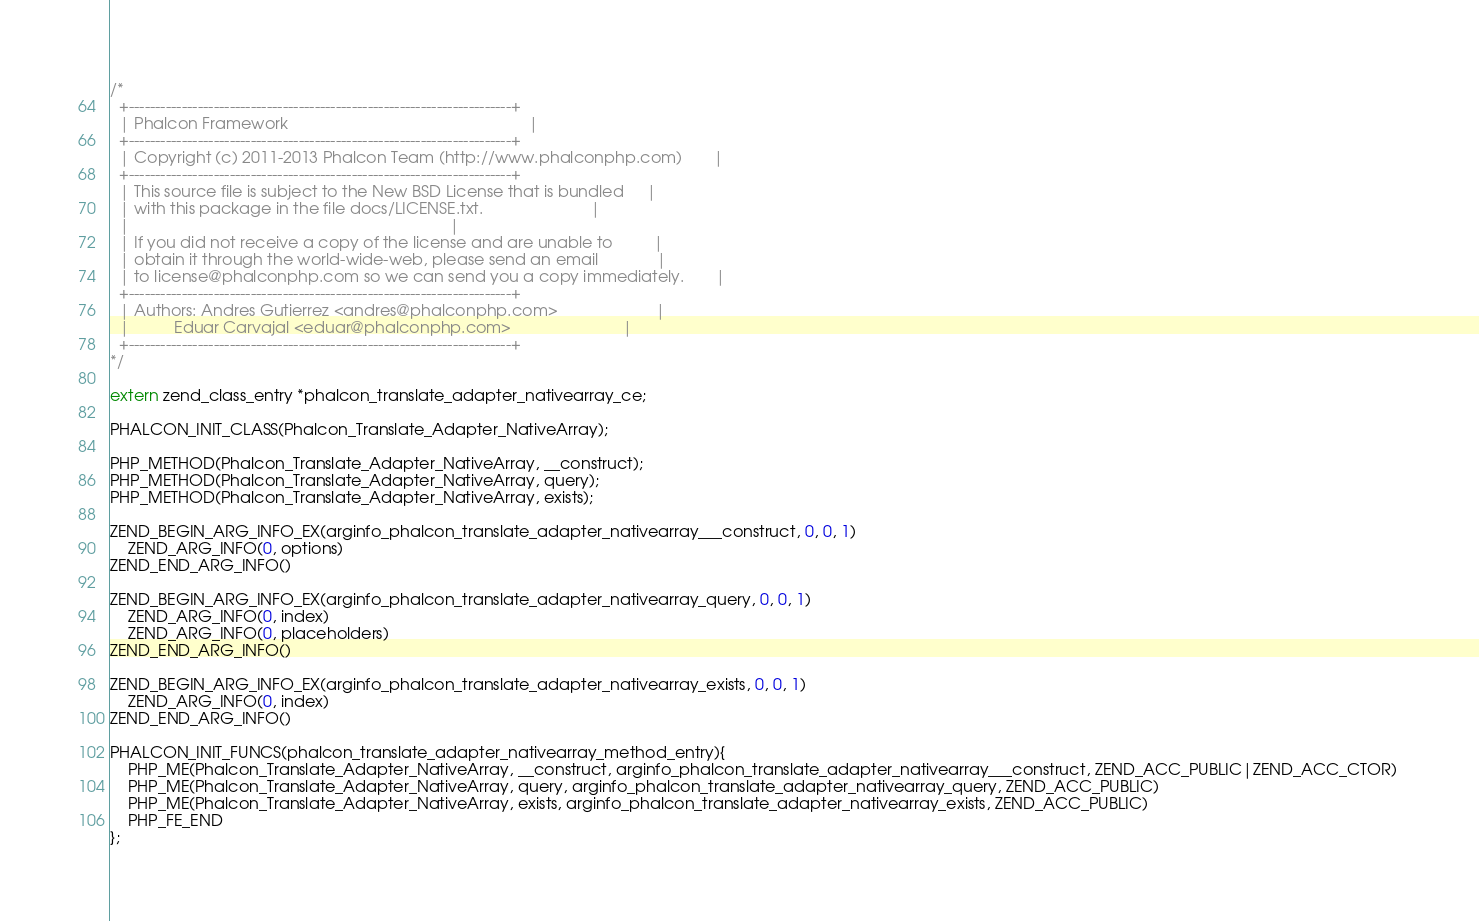<code> <loc_0><loc_0><loc_500><loc_500><_C_>
/*
  +------------------------------------------------------------------------+
  | Phalcon Framework                                                      |
  +------------------------------------------------------------------------+
  | Copyright (c) 2011-2013 Phalcon Team (http://www.phalconphp.com)       |
  +------------------------------------------------------------------------+
  | This source file is subject to the New BSD License that is bundled     |
  | with this package in the file docs/LICENSE.txt.                        |
  |                                                                        |
  | If you did not receive a copy of the license and are unable to         |
  | obtain it through the world-wide-web, please send an email             |
  | to license@phalconphp.com so we can send you a copy immediately.       |
  +------------------------------------------------------------------------+
  | Authors: Andres Gutierrez <andres@phalconphp.com>                      |
  |          Eduar Carvajal <eduar@phalconphp.com>                         |
  +------------------------------------------------------------------------+
*/

extern zend_class_entry *phalcon_translate_adapter_nativearray_ce;

PHALCON_INIT_CLASS(Phalcon_Translate_Adapter_NativeArray);

PHP_METHOD(Phalcon_Translate_Adapter_NativeArray, __construct);
PHP_METHOD(Phalcon_Translate_Adapter_NativeArray, query);
PHP_METHOD(Phalcon_Translate_Adapter_NativeArray, exists);

ZEND_BEGIN_ARG_INFO_EX(arginfo_phalcon_translate_adapter_nativearray___construct, 0, 0, 1)
	ZEND_ARG_INFO(0, options)
ZEND_END_ARG_INFO()

ZEND_BEGIN_ARG_INFO_EX(arginfo_phalcon_translate_adapter_nativearray_query, 0, 0, 1)
	ZEND_ARG_INFO(0, index)
	ZEND_ARG_INFO(0, placeholders)
ZEND_END_ARG_INFO()

ZEND_BEGIN_ARG_INFO_EX(arginfo_phalcon_translate_adapter_nativearray_exists, 0, 0, 1)
	ZEND_ARG_INFO(0, index)
ZEND_END_ARG_INFO()

PHALCON_INIT_FUNCS(phalcon_translate_adapter_nativearray_method_entry){
	PHP_ME(Phalcon_Translate_Adapter_NativeArray, __construct, arginfo_phalcon_translate_adapter_nativearray___construct, ZEND_ACC_PUBLIC|ZEND_ACC_CTOR) 
	PHP_ME(Phalcon_Translate_Adapter_NativeArray, query, arginfo_phalcon_translate_adapter_nativearray_query, ZEND_ACC_PUBLIC) 
	PHP_ME(Phalcon_Translate_Adapter_NativeArray, exists, arginfo_phalcon_translate_adapter_nativearray_exists, ZEND_ACC_PUBLIC) 
	PHP_FE_END
};

</code> 